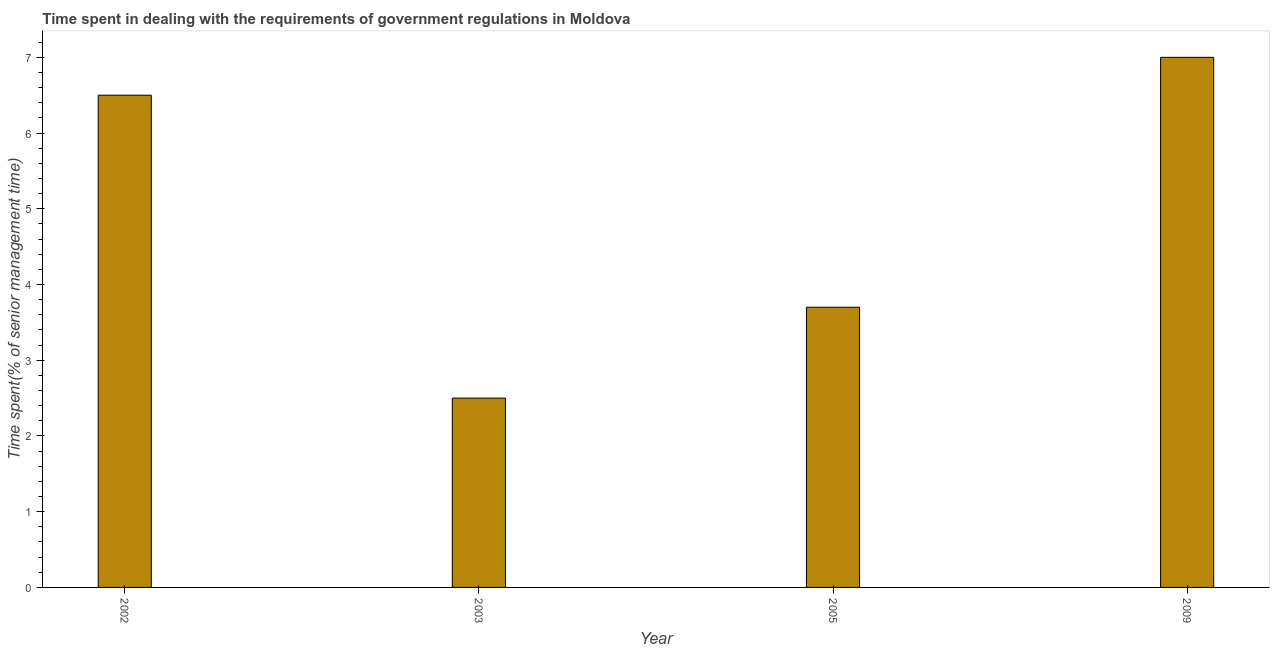Does the graph contain grids?
Ensure brevity in your answer.  No. What is the title of the graph?
Ensure brevity in your answer.  Time spent in dealing with the requirements of government regulations in Moldova. What is the label or title of the Y-axis?
Your response must be concise. Time spent(% of senior management time). Across all years, what is the maximum time spent in dealing with government regulations?
Your response must be concise. 7. In which year was the time spent in dealing with government regulations maximum?
Give a very brief answer. 2009. In which year was the time spent in dealing with government regulations minimum?
Offer a terse response. 2003. What is the sum of the time spent in dealing with government regulations?
Offer a very short reply. 19.7. What is the difference between the time spent in dealing with government regulations in 2002 and 2003?
Offer a very short reply. 4. What is the average time spent in dealing with government regulations per year?
Your answer should be very brief. 4.92. What is the median time spent in dealing with government regulations?
Give a very brief answer. 5.1. What is the ratio of the time spent in dealing with government regulations in 2002 to that in 2009?
Offer a very short reply. 0.93. What is the difference between the highest and the lowest time spent in dealing with government regulations?
Ensure brevity in your answer.  4.5. How many bars are there?
Offer a very short reply. 4. Are all the bars in the graph horizontal?
Offer a very short reply. No. How many years are there in the graph?
Offer a terse response. 4. What is the difference between two consecutive major ticks on the Y-axis?
Your answer should be very brief. 1. Are the values on the major ticks of Y-axis written in scientific E-notation?
Ensure brevity in your answer.  No. What is the Time spent(% of senior management time) in 2002?
Make the answer very short. 6.5. What is the Time spent(% of senior management time) of 2003?
Ensure brevity in your answer.  2.5. What is the Time spent(% of senior management time) in 2009?
Offer a terse response. 7. What is the difference between the Time spent(% of senior management time) in 2002 and 2003?
Keep it short and to the point. 4. What is the difference between the Time spent(% of senior management time) in 2002 and 2005?
Make the answer very short. 2.8. What is the difference between the Time spent(% of senior management time) in 2002 and 2009?
Provide a succinct answer. -0.5. What is the difference between the Time spent(% of senior management time) in 2003 and 2009?
Give a very brief answer. -4.5. What is the difference between the Time spent(% of senior management time) in 2005 and 2009?
Your answer should be very brief. -3.3. What is the ratio of the Time spent(% of senior management time) in 2002 to that in 2005?
Offer a terse response. 1.76. What is the ratio of the Time spent(% of senior management time) in 2002 to that in 2009?
Your response must be concise. 0.93. What is the ratio of the Time spent(% of senior management time) in 2003 to that in 2005?
Make the answer very short. 0.68. What is the ratio of the Time spent(% of senior management time) in 2003 to that in 2009?
Your answer should be very brief. 0.36. What is the ratio of the Time spent(% of senior management time) in 2005 to that in 2009?
Your answer should be compact. 0.53. 